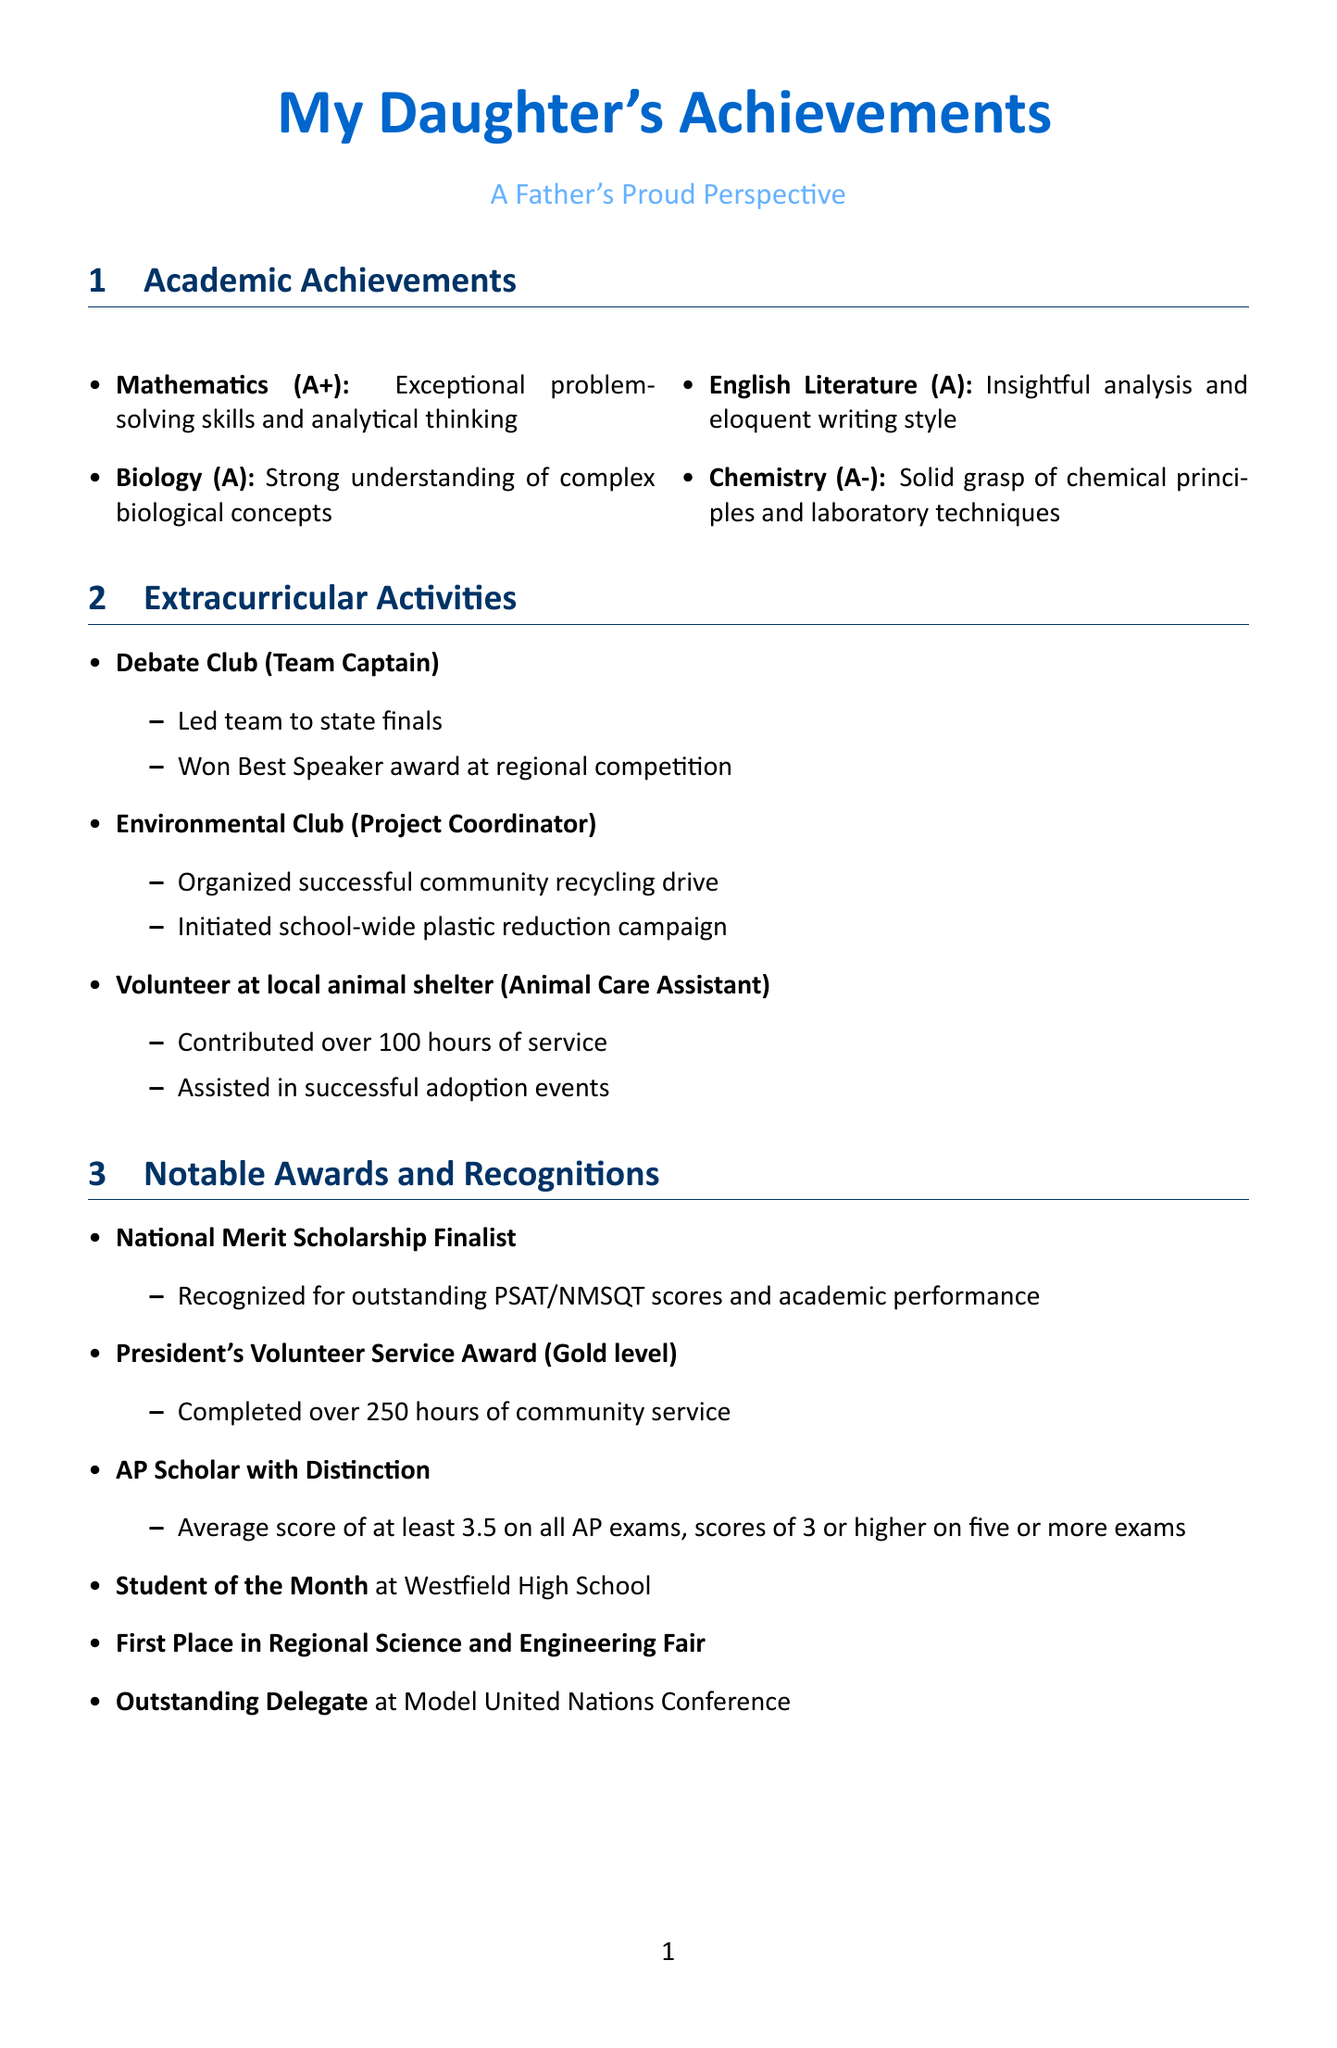What grade did she receive in Mathematics? The document states that she received an A+ in Mathematics.
Answer: A+ Who is the team captain of the Debate Club? The document indicates that she is the Team Captain of the Debate Club.
Answer: She What award recognizes outstanding PSAT/NMSQT scores? The award recognized for outstanding PSAT/NMSQT scores is the National Merit Scholarship Finalist.
Answer: National Merit Scholarship Finalist How many hours did she contribute as a volunteer at the animal shelter? The document mentions she contributed over 100 hours of service.
Answer: Over 100 hours What was her proudest moment mentioned in the document? The proudest moment mentioned is watching her deliver a passionate speech at the state debate finals.
Answer: Watching her deliver a passionate speech at the state debate finals What is one of her future aspirations? The document states her aspiration to study Environmental Science at Stanford University.
Answer: Studying Environmental Science at Stanford University How many awards or recognitions are listed in the document? There are seven notable awards and recognitions listed in the document.
Answer: Seven What role did she have in the Environmental Club? The document indicates she was the Project Coordinator in the Environmental Club.
Answer: Project Coordinator What type of support does her father provide during challenging times? The document mentions that he listens and offers advice during challenging times.
Answer: Listening and offering advice 